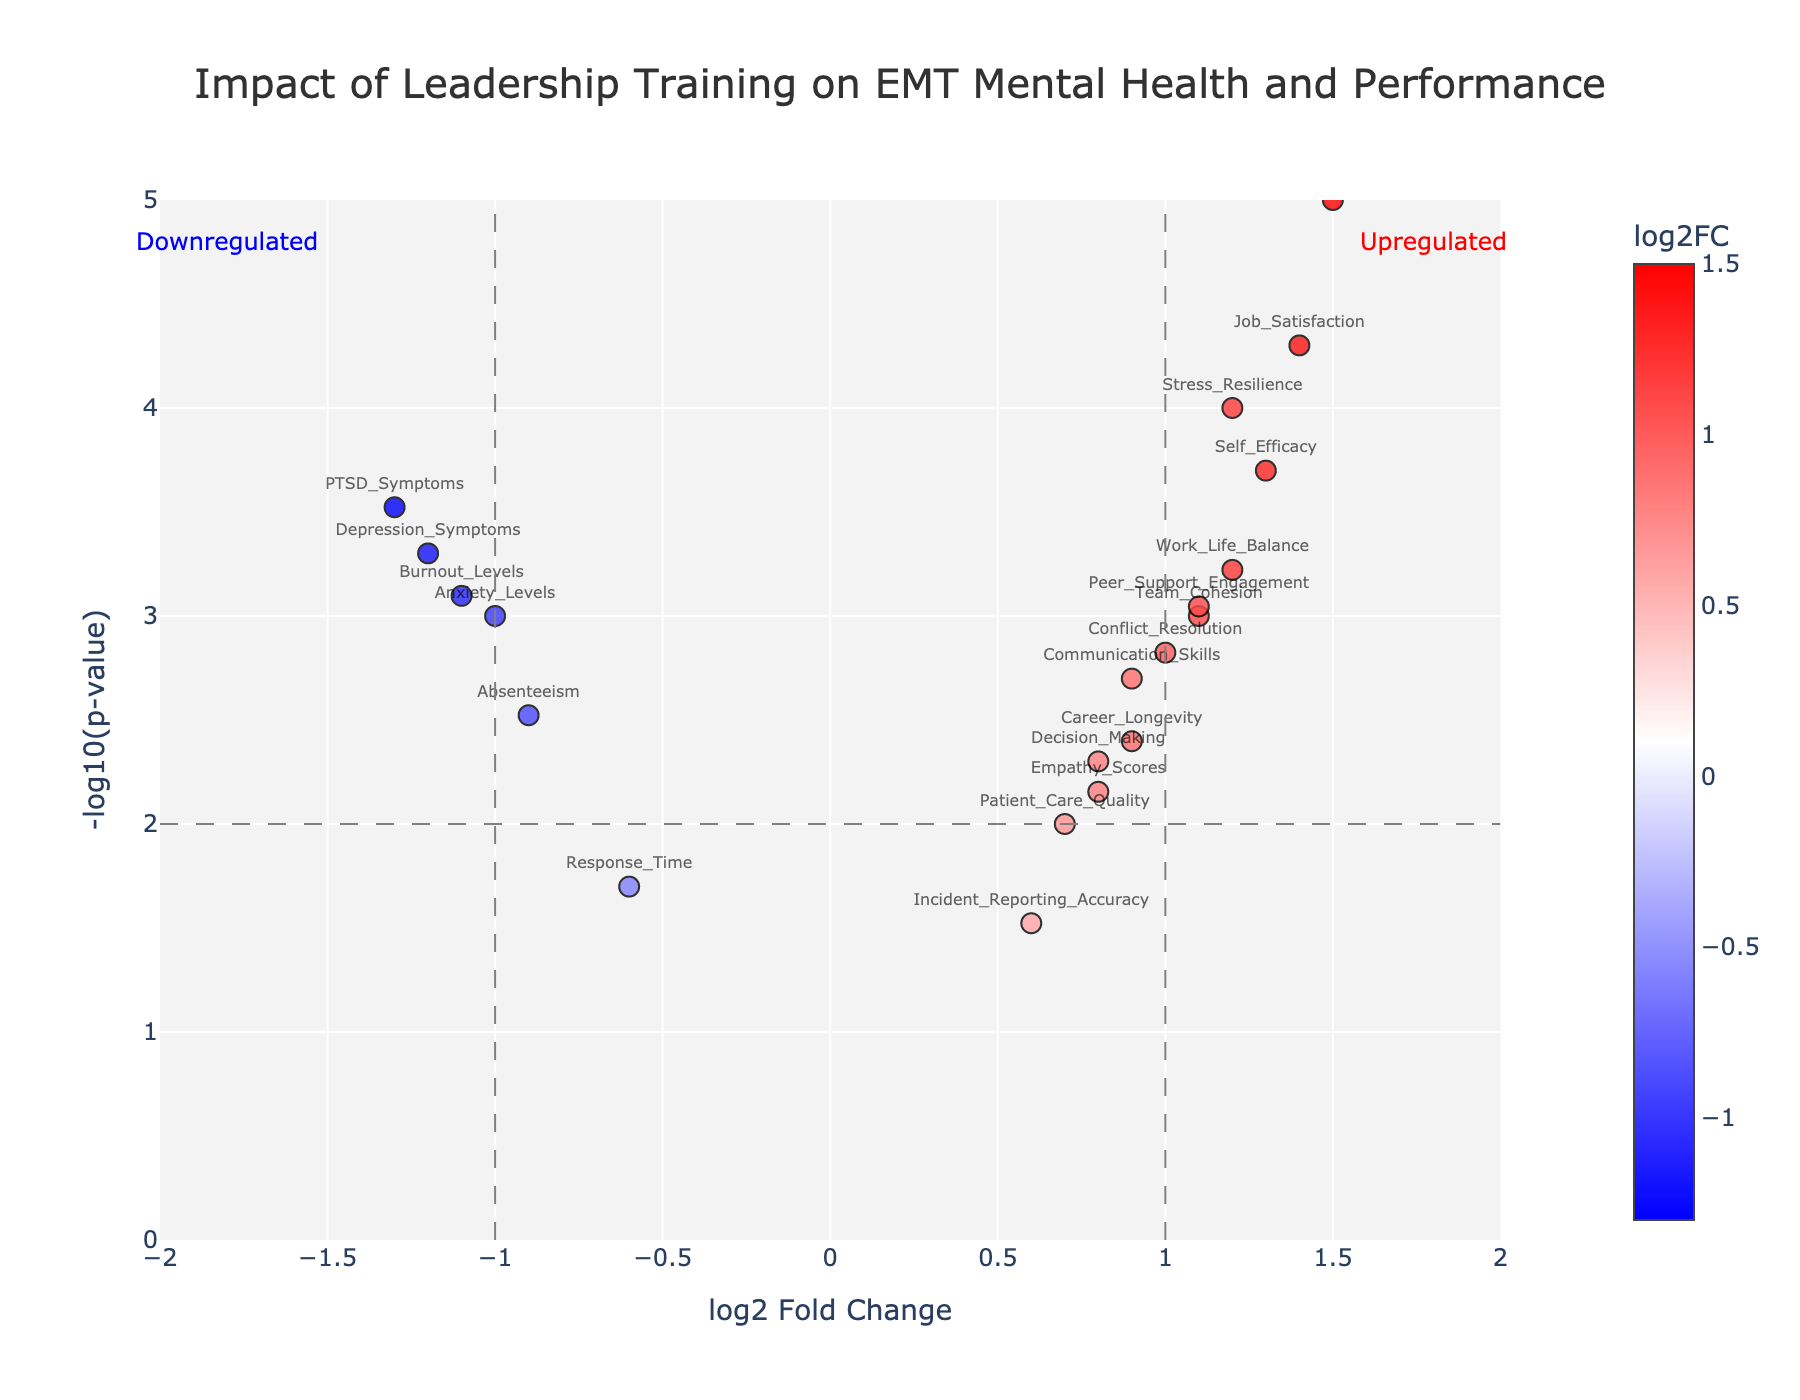Which variable has the highest log2 Fold Change? By looking at the x-axis, the variable with the highest log2 Fold Change is the one that is farthest to the right.
Answer: Emotional_Intelligence Which variables are significantly downregulated? Downregulated variables have negative log2 Fold Change. Check the data points on the left side of the plot that also have high -log10(p-value) (above the threshold line).
Answer: PTSD_Symptoms, Burnout_Levels, Response_Time, Absenteeism, Anxiety_Levels, Depression_Symptoms What is the significance threshold for -log10(p-value)? The significance threshold is represented by the horizontal dashed line, which intersects the y-axis at a specific value.
Answer: 2 How does Work_Life_Balance compare to Career_Longevity in terms of log2 Fold Change? Locate both data points on the x-axis and compare their positions. The one further to the right has a higher log2 Fold Change.
Answer: Work_Life_Balance has a higher log2 Fold Change compared to Career_Longevity How many variables have a p-value less than 0.001? Data points with p-values less than 0.001 would have -log10(p-value) greater than 3. Check how many data points lie above the y-value of 3.
Answer: 7 What is the log2 Fold Change and -log10(p-value) for Job_Satisfaction? Identify the data point labeled "Job_Satisfaction" and read the coordinates.
Answer: log2 Fold Change: 1.4, -log10(p-value): 4.3 Which variable has the lowest p-value and what is its log2 Fold Change? The variable with the lowest p-value will have the highest -log10(p-value). Identify this point and then find its log2 Fold Change.
Answer: Emotional_Intelligence, log2 Fold Change: 1.5 Between Stress_Resilience and Team_Cohesion, which one has a higher significance? Compare their -log10(p-value) values directly by looking at their y-axis positions.
Answer: Stress_Resilience Are there any variables that are neither upregulated nor downregulated significantly? Variables near the vertical dashed lines (log2 Fold Change close to zero) and below the horizontal dashed line (-log10(p-value) below 2) are neither upregulated nor downregulated significantly.
Answer: None What is the impact of leadership training on PTSD_Symptoms based on the plot? Find the data point labeled "PTSD_Symptoms" and observe if it is on the left or right side of the plot, and whether it is above the significance threshold.
Answer: PTSD_Symptoms are significantly downregulated 